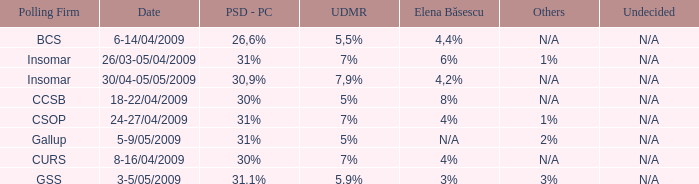What is the elena basescu when the poling firm of gallup? N/A. 